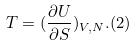<formula> <loc_0><loc_0><loc_500><loc_500>T = ( \frac { \partial U } { \partial S } ) _ { V , N } . ( 2 )</formula> 